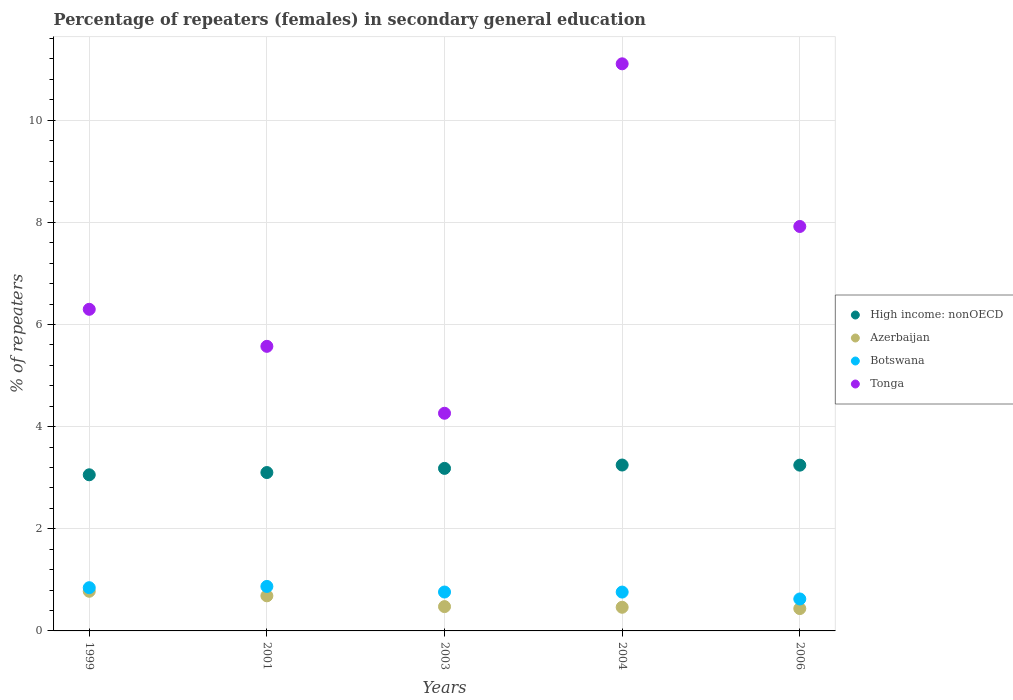How many different coloured dotlines are there?
Provide a succinct answer. 4. Is the number of dotlines equal to the number of legend labels?
Give a very brief answer. Yes. What is the percentage of female repeaters in High income: nonOECD in 2006?
Your answer should be very brief. 3.25. Across all years, what is the maximum percentage of female repeaters in High income: nonOECD?
Make the answer very short. 3.25. Across all years, what is the minimum percentage of female repeaters in Tonga?
Make the answer very short. 4.26. What is the total percentage of female repeaters in Botswana in the graph?
Provide a succinct answer. 3.87. What is the difference between the percentage of female repeaters in Azerbaijan in 2003 and that in 2004?
Give a very brief answer. 0.01. What is the difference between the percentage of female repeaters in Azerbaijan in 2006 and the percentage of female repeaters in Botswana in 2003?
Ensure brevity in your answer.  -0.32. What is the average percentage of female repeaters in Tonga per year?
Give a very brief answer. 7.03. In the year 2003, what is the difference between the percentage of female repeaters in Botswana and percentage of female repeaters in High income: nonOECD?
Offer a very short reply. -2.42. What is the ratio of the percentage of female repeaters in High income: nonOECD in 2004 to that in 2006?
Offer a very short reply. 1. Is the difference between the percentage of female repeaters in Botswana in 1999 and 2006 greater than the difference between the percentage of female repeaters in High income: nonOECD in 1999 and 2006?
Your answer should be compact. Yes. What is the difference between the highest and the second highest percentage of female repeaters in Azerbaijan?
Provide a succinct answer. 0.09. What is the difference between the highest and the lowest percentage of female repeaters in Botswana?
Offer a terse response. 0.25. Is the percentage of female repeaters in Tonga strictly greater than the percentage of female repeaters in High income: nonOECD over the years?
Make the answer very short. Yes. Are the values on the major ticks of Y-axis written in scientific E-notation?
Make the answer very short. No. Does the graph contain any zero values?
Offer a terse response. No. Does the graph contain grids?
Keep it short and to the point. Yes. How are the legend labels stacked?
Make the answer very short. Vertical. What is the title of the graph?
Keep it short and to the point. Percentage of repeaters (females) in secondary general education. What is the label or title of the Y-axis?
Ensure brevity in your answer.  % of repeaters. What is the % of repeaters in High income: nonOECD in 1999?
Your answer should be compact. 3.06. What is the % of repeaters in Azerbaijan in 1999?
Provide a short and direct response. 0.78. What is the % of repeaters in Botswana in 1999?
Ensure brevity in your answer.  0.85. What is the % of repeaters in Tonga in 1999?
Your answer should be very brief. 6.3. What is the % of repeaters of High income: nonOECD in 2001?
Offer a terse response. 3.1. What is the % of repeaters in Azerbaijan in 2001?
Offer a very short reply. 0.69. What is the % of repeaters in Botswana in 2001?
Provide a short and direct response. 0.87. What is the % of repeaters of Tonga in 2001?
Your response must be concise. 5.57. What is the % of repeaters in High income: nonOECD in 2003?
Make the answer very short. 3.18. What is the % of repeaters of Azerbaijan in 2003?
Make the answer very short. 0.48. What is the % of repeaters of Botswana in 2003?
Provide a succinct answer. 0.76. What is the % of repeaters of Tonga in 2003?
Your answer should be very brief. 4.26. What is the % of repeaters of High income: nonOECD in 2004?
Provide a succinct answer. 3.25. What is the % of repeaters of Azerbaijan in 2004?
Offer a very short reply. 0.46. What is the % of repeaters in Botswana in 2004?
Give a very brief answer. 0.76. What is the % of repeaters in Tonga in 2004?
Keep it short and to the point. 11.1. What is the % of repeaters of High income: nonOECD in 2006?
Ensure brevity in your answer.  3.25. What is the % of repeaters in Azerbaijan in 2006?
Provide a short and direct response. 0.44. What is the % of repeaters of Botswana in 2006?
Offer a very short reply. 0.63. What is the % of repeaters in Tonga in 2006?
Provide a succinct answer. 7.92. Across all years, what is the maximum % of repeaters in High income: nonOECD?
Give a very brief answer. 3.25. Across all years, what is the maximum % of repeaters in Azerbaijan?
Your answer should be compact. 0.78. Across all years, what is the maximum % of repeaters of Botswana?
Ensure brevity in your answer.  0.87. Across all years, what is the maximum % of repeaters of Tonga?
Keep it short and to the point. 11.1. Across all years, what is the minimum % of repeaters in High income: nonOECD?
Provide a succinct answer. 3.06. Across all years, what is the minimum % of repeaters of Azerbaijan?
Keep it short and to the point. 0.44. Across all years, what is the minimum % of repeaters in Botswana?
Your response must be concise. 0.63. Across all years, what is the minimum % of repeaters of Tonga?
Give a very brief answer. 4.26. What is the total % of repeaters of High income: nonOECD in the graph?
Ensure brevity in your answer.  15.84. What is the total % of repeaters in Azerbaijan in the graph?
Your answer should be compact. 2.84. What is the total % of repeaters in Botswana in the graph?
Your answer should be compact. 3.87. What is the total % of repeaters of Tonga in the graph?
Your answer should be very brief. 35.16. What is the difference between the % of repeaters in High income: nonOECD in 1999 and that in 2001?
Provide a short and direct response. -0.04. What is the difference between the % of repeaters of Azerbaijan in 1999 and that in 2001?
Keep it short and to the point. 0.09. What is the difference between the % of repeaters of Botswana in 1999 and that in 2001?
Your answer should be compact. -0.02. What is the difference between the % of repeaters of Tonga in 1999 and that in 2001?
Keep it short and to the point. 0.73. What is the difference between the % of repeaters in High income: nonOECD in 1999 and that in 2003?
Offer a very short reply. -0.13. What is the difference between the % of repeaters in Azerbaijan in 1999 and that in 2003?
Give a very brief answer. 0.3. What is the difference between the % of repeaters of Botswana in 1999 and that in 2003?
Your response must be concise. 0.08. What is the difference between the % of repeaters in Tonga in 1999 and that in 2003?
Your answer should be very brief. 2.04. What is the difference between the % of repeaters of High income: nonOECD in 1999 and that in 2004?
Provide a short and direct response. -0.19. What is the difference between the % of repeaters in Azerbaijan in 1999 and that in 2004?
Keep it short and to the point. 0.31. What is the difference between the % of repeaters in Botswana in 1999 and that in 2004?
Your answer should be very brief. 0.09. What is the difference between the % of repeaters of Tonga in 1999 and that in 2004?
Give a very brief answer. -4.81. What is the difference between the % of repeaters of High income: nonOECD in 1999 and that in 2006?
Make the answer very short. -0.19. What is the difference between the % of repeaters in Azerbaijan in 1999 and that in 2006?
Offer a terse response. 0.34. What is the difference between the % of repeaters in Botswana in 1999 and that in 2006?
Provide a short and direct response. 0.22. What is the difference between the % of repeaters of Tonga in 1999 and that in 2006?
Offer a very short reply. -1.62. What is the difference between the % of repeaters of High income: nonOECD in 2001 and that in 2003?
Your response must be concise. -0.08. What is the difference between the % of repeaters in Azerbaijan in 2001 and that in 2003?
Give a very brief answer. 0.21. What is the difference between the % of repeaters of Botswana in 2001 and that in 2003?
Give a very brief answer. 0.11. What is the difference between the % of repeaters of Tonga in 2001 and that in 2003?
Keep it short and to the point. 1.31. What is the difference between the % of repeaters in High income: nonOECD in 2001 and that in 2004?
Ensure brevity in your answer.  -0.15. What is the difference between the % of repeaters of Azerbaijan in 2001 and that in 2004?
Provide a short and direct response. 0.22. What is the difference between the % of repeaters in Botswana in 2001 and that in 2004?
Make the answer very short. 0.11. What is the difference between the % of repeaters of Tonga in 2001 and that in 2004?
Your answer should be very brief. -5.53. What is the difference between the % of repeaters in High income: nonOECD in 2001 and that in 2006?
Your response must be concise. -0.14. What is the difference between the % of repeaters in Azerbaijan in 2001 and that in 2006?
Provide a short and direct response. 0.25. What is the difference between the % of repeaters in Botswana in 2001 and that in 2006?
Your response must be concise. 0.25. What is the difference between the % of repeaters of Tonga in 2001 and that in 2006?
Provide a short and direct response. -2.35. What is the difference between the % of repeaters in High income: nonOECD in 2003 and that in 2004?
Provide a short and direct response. -0.07. What is the difference between the % of repeaters in Azerbaijan in 2003 and that in 2004?
Offer a very short reply. 0.01. What is the difference between the % of repeaters of Tonga in 2003 and that in 2004?
Keep it short and to the point. -6.84. What is the difference between the % of repeaters of High income: nonOECD in 2003 and that in 2006?
Your answer should be very brief. -0.06. What is the difference between the % of repeaters of Azerbaijan in 2003 and that in 2006?
Make the answer very short. 0.04. What is the difference between the % of repeaters in Botswana in 2003 and that in 2006?
Give a very brief answer. 0.14. What is the difference between the % of repeaters in Tonga in 2003 and that in 2006?
Provide a succinct answer. -3.66. What is the difference between the % of repeaters of High income: nonOECD in 2004 and that in 2006?
Make the answer very short. 0. What is the difference between the % of repeaters of Azerbaijan in 2004 and that in 2006?
Give a very brief answer. 0.03. What is the difference between the % of repeaters in Botswana in 2004 and that in 2006?
Ensure brevity in your answer.  0.13. What is the difference between the % of repeaters in Tonga in 2004 and that in 2006?
Your answer should be compact. 3.19. What is the difference between the % of repeaters in High income: nonOECD in 1999 and the % of repeaters in Azerbaijan in 2001?
Offer a very short reply. 2.37. What is the difference between the % of repeaters in High income: nonOECD in 1999 and the % of repeaters in Botswana in 2001?
Make the answer very short. 2.19. What is the difference between the % of repeaters in High income: nonOECD in 1999 and the % of repeaters in Tonga in 2001?
Give a very brief answer. -2.52. What is the difference between the % of repeaters in Azerbaijan in 1999 and the % of repeaters in Botswana in 2001?
Keep it short and to the point. -0.09. What is the difference between the % of repeaters in Azerbaijan in 1999 and the % of repeaters in Tonga in 2001?
Your response must be concise. -4.8. What is the difference between the % of repeaters in Botswana in 1999 and the % of repeaters in Tonga in 2001?
Provide a succinct answer. -4.73. What is the difference between the % of repeaters in High income: nonOECD in 1999 and the % of repeaters in Azerbaijan in 2003?
Make the answer very short. 2.58. What is the difference between the % of repeaters of High income: nonOECD in 1999 and the % of repeaters of Botswana in 2003?
Offer a very short reply. 2.3. What is the difference between the % of repeaters in High income: nonOECD in 1999 and the % of repeaters in Tonga in 2003?
Give a very brief answer. -1.21. What is the difference between the % of repeaters of Azerbaijan in 1999 and the % of repeaters of Botswana in 2003?
Offer a very short reply. 0.01. What is the difference between the % of repeaters in Azerbaijan in 1999 and the % of repeaters in Tonga in 2003?
Offer a very short reply. -3.49. What is the difference between the % of repeaters in Botswana in 1999 and the % of repeaters in Tonga in 2003?
Offer a terse response. -3.42. What is the difference between the % of repeaters in High income: nonOECD in 1999 and the % of repeaters in Azerbaijan in 2004?
Your answer should be compact. 2.59. What is the difference between the % of repeaters in High income: nonOECD in 1999 and the % of repeaters in Botswana in 2004?
Make the answer very short. 2.3. What is the difference between the % of repeaters of High income: nonOECD in 1999 and the % of repeaters of Tonga in 2004?
Ensure brevity in your answer.  -8.05. What is the difference between the % of repeaters in Azerbaijan in 1999 and the % of repeaters in Botswana in 2004?
Your answer should be compact. 0.02. What is the difference between the % of repeaters in Azerbaijan in 1999 and the % of repeaters in Tonga in 2004?
Keep it short and to the point. -10.33. What is the difference between the % of repeaters in Botswana in 1999 and the % of repeaters in Tonga in 2004?
Provide a succinct answer. -10.26. What is the difference between the % of repeaters in High income: nonOECD in 1999 and the % of repeaters in Azerbaijan in 2006?
Keep it short and to the point. 2.62. What is the difference between the % of repeaters in High income: nonOECD in 1999 and the % of repeaters in Botswana in 2006?
Give a very brief answer. 2.43. What is the difference between the % of repeaters of High income: nonOECD in 1999 and the % of repeaters of Tonga in 2006?
Provide a succinct answer. -4.86. What is the difference between the % of repeaters of Azerbaijan in 1999 and the % of repeaters of Botswana in 2006?
Provide a succinct answer. 0.15. What is the difference between the % of repeaters in Azerbaijan in 1999 and the % of repeaters in Tonga in 2006?
Make the answer very short. -7.14. What is the difference between the % of repeaters of Botswana in 1999 and the % of repeaters of Tonga in 2006?
Your answer should be compact. -7.07. What is the difference between the % of repeaters in High income: nonOECD in 2001 and the % of repeaters in Azerbaijan in 2003?
Your response must be concise. 2.63. What is the difference between the % of repeaters in High income: nonOECD in 2001 and the % of repeaters in Botswana in 2003?
Offer a terse response. 2.34. What is the difference between the % of repeaters in High income: nonOECD in 2001 and the % of repeaters in Tonga in 2003?
Keep it short and to the point. -1.16. What is the difference between the % of repeaters of Azerbaijan in 2001 and the % of repeaters of Botswana in 2003?
Offer a very short reply. -0.07. What is the difference between the % of repeaters of Azerbaijan in 2001 and the % of repeaters of Tonga in 2003?
Keep it short and to the point. -3.58. What is the difference between the % of repeaters of Botswana in 2001 and the % of repeaters of Tonga in 2003?
Provide a short and direct response. -3.39. What is the difference between the % of repeaters of High income: nonOECD in 2001 and the % of repeaters of Azerbaijan in 2004?
Provide a short and direct response. 2.64. What is the difference between the % of repeaters in High income: nonOECD in 2001 and the % of repeaters in Botswana in 2004?
Offer a very short reply. 2.34. What is the difference between the % of repeaters in High income: nonOECD in 2001 and the % of repeaters in Tonga in 2004?
Your response must be concise. -8. What is the difference between the % of repeaters in Azerbaijan in 2001 and the % of repeaters in Botswana in 2004?
Ensure brevity in your answer.  -0.07. What is the difference between the % of repeaters of Azerbaijan in 2001 and the % of repeaters of Tonga in 2004?
Offer a very short reply. -10.42. What is the difference between the % of repeaters of Botswana in 2001 and the % of repeaters of Tonga in 2004?
Ensure brevity in your answer.  -10.23. What is the difference between the % of repeaters in High income: nonOECD in 2001 and the % of repeaters in Azerbaijan in 2006?
Provide a short and direct response. 2.66. What is the difference between the % of repeaters of High income: nonOECD in 2001 and the % of repeaters of Botswana in 2006?
Ensure brevity in your answer.  2.48. What is the difference between the % of repeaters in High income: nonOECD in 2001 and the % of repeaters in Tonga in 2006?
Ensure brevity in your answer.  -4.82. What is the difference between the % of repeaters in Azerbaijan in 2001 and the % of repeaters in Botswana in 2006?
Give a very brief answer. 0.06. What is the difference between the % of repeaters of Azerbaijan in 2001 and the % of repeaters of Tonga in 2006?
Ensure brevity in your answer.  -7.23. What is the difference between the % of repeaters of Botswana in 2001 and the % of repeaters of Tonga in 2006?
Your answer should be compact. -7.05. What is the difference between the % of repeaters in High income: nonOECD in 2003 and the % of repeaters in Azerbaijan in 2004?
Your response must be concise. 2.72. What is the difference between the % of repeaters in High income: nonOECD in 2003 and the % of repeaters in Botswana in 2004?
Your response must be concise. 2.42. What is the difference between the % of repeaters of High income: nonOECD in 2003 and the % of repeaters of Tonga in 2004?
Offer a very short reply. -7.92. What is the difference between the % of repeaters of Azerbaijan in 2003 and the % of repeaters of Botswana in 2004?
Offer a terse response. -0.28. What is the difference between the % of repeaters of Azerbaijan in 2003 and the % of repeaters of Tonga in 2004?
Your answer should be very brief. -10.63. What is the difference between the % of repeaters in Botswana in 2003 and the % of repeaters in Tonga in 2004?
Provide a succinct answer. -10.34. What is the difference between the % of repeaters in High income: nonOECD in 2003 and the % of repeaters in Azerbaijan in 2006?
Keep it short and to the point. 2.74. What is the difference between the % of repeaters of High income: nonOECD in 2003 and the % of repeaters of Botswana in 2006?
Your answer should be very brief. 2.56. What is the difference between the % of repeaters in High income: nonOECD in 2003 and the % of repeaters in Tonga in 2006?
Provide a succinct answer. -4.74. What is the difference between the % of repeaters in Azerbaijan in 2003 and the % of repeaters in Botswana in 2006?
Provide a succinct answer. -0.15. What is the difference between the % of repeaters in Azerbaijan in 2003 and the % of repeaters in Tonga in 2006?
Make the answer very short. -7.44. What is the difference between the % of repeaters in Botswana in 2003 and the % of repeaters in Tonga in 2006?
Ensure brevity in your answer.  -7.16. What is the difference between the % of repeaters in High income: nonOECD in 2004 and the % of repeaters in Azerbaijan in 2006?
Your response must be concise. 2.81. What is the difference between the % of repeaters in High income: nonOECD in 2004 and the % of repeaters in Botswana in 2006?
Offer a terse response. 2.62. What is the difference between the % of repeaters in High income: nonOECD in 2004 and the % of repeaters in Tonga in 2006?
Make the answer very short. -4.67. What is the difference between the % of repeaters in Azerbaijan in 2004 and the % of repeaters in Botswana in 2006?
Give a very brief answer. -0.16. What is the difference between the % of repeaters of Azerbaijan in 2004 and the % of repeaters of Tonga in 2006?
Ensure brevity in your answer.  -7.46. What is the difference between the % of repeaters in Botswana in 2004 and the % of repeaters in Tonga in 2006?
Offer a very short reply. -7.16. What is the average % of repeaters of High income: nonOECD per year?
Keep it short and to the point. 3.17. What is the average % of repeaters of Azerbaijan per year?
Keep it short and to the point. 0.57. What is the average % of repeaters in Botswana per year?
Your response must be concise. 0.77. What is the average % of repeaters of Tonga per year?
Offer a terse response. 7.03. In the year 1999, what is the difference between the % of repeaters of High income: nonOECD and % of repeaters of Azerbaijan?
Give a very brief answer. 2.28. In the year 1999, what is the difference between the % of repeaters of High income: nonOECD and % of repeaters of Botswana?
Make the answer very short. 2.21. In the year 1999, what is the difference between the % of repeaters in High income: nonOECD and % of repeaters in Tonga?
Ensure brevity in your answer.  -3.24. In the year 1999, what is the difference between the % of repeaters of Azerbaijan and % of repeaters of Botswana?
Provide a short and direct response. -0.07. In the year 1999, what is the difference between the % of repeaters of Azerbaijan and % of repeaters of Tonga?
Provide a succinct answer. -5.52. In the year 1999, what is the difference between the % of repeaters in Botswana and % of repeaters in Tonga?
Keep it short and to the point. -5.45. In the year 2001, what is the difference between the % of repeaters of High income: nonOECD and % of repeaters of Azerbaijan?
Offer a terse response. 2.41. In the year 2001, what is the difference between the % of repeaters of High income: nonOECD and % of repeaters of Botswana?
Your answer should be compact. 2.23. In the year 2001, what is the difference between the % of repeaters of High income: nonOECD and % of repeaters of Tonga?
Offer a very short reply. -2.47. In the year 2001, what is the difference between the % of repeaters in Azerbaijan and % of repeaters in Botswana?
Offer a terse response. -0.18. In the year 2001, what is the difference between the % of repeaters in Azerbaijan and % of repeaters in Tonga?
Make the answer very short. -4.89. In the year 2001, what is the difference between the % of repeaters in Botswana and % of repeaters in Tonga?
Provide a succinct answer. -4.7. In the year 2003, what is the difference between the % of repeaters of High income: nonOECD and % of repeaters of Azerbaijan?
Offer a terse response. 2.71. In the year 2003, what is the difference between the % of repeaters in High income: nonOECD and % of repeaters in Botswana?
Your response must be concise. 2.42. In the year 2003, what is the difference between the % of repeaters in High income: nonOECD and % of repeaters in Tonga?
Offer a terse response. -1.08. In the year 2003, what is the difference between the % of repeaters in Azerbaijan and % of repeaters in Botswana?
Your answer should be very brief. -0.29. In the year 2003, what is the difference between the % of repeaters in Azerbaijan and % of repeaters in Tonga?
Provide a short and direct response. -3.79. In the year 2003, what is the difference between the % of repeaters in Botswana and % of repeaters in Tonga?
Offer a terse response. -3.5. In the year 2004, what is the difference between the % of repeaters of High income: nonOECD and % of repeaters of Azerbaijan?
Ensure brevity in your answer.  2.79. In the year 2004, what is the difference between the % of repeaters in High income: nonOECD and % of repeaters in Botswana?
Provide a short and direct response. 2.49. In the year 2004, what is the difference between the % of repeaters of High income: nonOECD and % of repeaters of Tonga?
Make the answer very short. -7.86. In the year 2004, what is the difference between the % of repeaters of Azerbaijan and % of repeaters of Botswana?
Your response must be concise. -0.3. In the year 2004, what is the difference between the % of repeaters in Azerbaijan and % of repeaters in Tonga?
Your response must be concise. -10.64. In the year 2004, what is the difference between the % of repeaters in Botswana and % of repeaters in Tonga?
Make the answer very short. -10.34. In the year 2006, what is the difference between the % of repeaters of High income: nonOECD and % of repeaters of Azerbaijan?
Provide a short and direct response. 2.81. In the year 2006, what is the difference between the % of repeaters in High income: nonOECD and % of repeaters in Botswana?
Provide a succinct answer. 2.62. In the year 2006, what is the difference between the % of repeaters of High income: nonOECD and % of repeaters of Tonga?
Your answer should be very brief. -4.67. In the year 2006, what is the difference between the % of repeaters of Azerbaijan and % of repeaters of Botswana?
Keep it short and to the point. -0.19. In the year 2006, what is the difference between the % of repeaters of Azerbaijan and % of repeaters of Tonga?
Your answer should be compact. -7.48. In the year 2006, what is the difference between the % of repeaters of Botswana and % of repeaters of Tonga?
Your answer should be compact. -7.29. What is the ratio of the % of repeaters of High income: nonOECD in 1999 to that in 2001?
Keep it short and to the point. 0.99. What is the ratio of the % of repeaters in Azerbaijan in 1999 to that in 2001?
Ensure brevity in your answer.  1.13. What is the ratio of the % of repeaters in Botswana in 1999 to that in 2001?
Provide a short and direct response. 0.97. What is the ratio of the % of repeaters in Tonga in 1999 to that in 2001?
Keep it short and to the point. 1.13. What is the ratio of the % of repeaters in High income: nonOECD in 1999 to that in 2003?
Keep it short and to the point. 0.96. What is the ratio of the % of repeaters in Azerbaijan in 1999 to that in 2003?
Give a very brief answer. 1.63. What is the ratio of the % of repeaters in Botswana in 1999 to that in 2003?
Ensure brevity in your answer.  1.11. What is the ratio of the % of repeaters in Tonga in 1999 to that in 2003?
Ensure brevity in your answer.  1.48. What is the ratio of the % of repeaters in High income: nonOECD in 1999 to that in 2004?
Your response must be concise. 0.94. What is the ratio of the % of repeaters in Azerbaijan in 1999 to that in 2004?
Provide a succinct answer. 1.68. What is the ratio of the % of repeaters in Botswana in 1999 to that in 2004?
Provide a short and direct response. 1.11. What is the ratio of the % of repeaters in Tonga in 1999 to that in 2004?
Give a very brief answer. 0.57. What is the ratio of the % of repeaters in High income: nonOECD in 1999 to that in 2006?
Make the answer very short. 0.94. What is the ratio of the % of repeaters of Azerbaijan in 1999 to that in 2006?
Ensure brevity in your answer.  1.77. What is the ratio of the % of repeaters of Botswana in 1999 to that in 2006?
Make the answer very short. 1.35. What is the ratio of the % of repeaters in Tonga in 1999 to that in 2006?
Ensure brevity in your answer.  0.8. What is the ratio of the % of repeaters of High income: nonOECD in 2001 to that in 2003?
Keep it short and to the point. 0.97. What is the ratio of the % of repeaters of Azerbaijan in 2001 to that in 2003?
Provide a short and direct response. 1.44. What is the ratio of the % of repeaters in Botswana in 2001 to that in 2003?
Your answer should be compact. 1.14. What is the ratio of the % of repeaters of Tonga in 2001 to that in 2003?
Provide a succinct answer. 1.31. What is the ratio of the % of repeaters in High income: nonOECD in 2001 to that in 2004?
Make the answer very short. 0.95. What is the ratio of the % of repeaters of Azerbaijan in 2001 to that in 2004?
Make the answer very short. 1.48. What is the ratio of the % of repeaters in Botswana in 2001 to that in 2004?
Provide a short and direct response. 1.15. What is the ratio of the % of repeaters in Tonga in 2001 to that in 2004?
Your answer should be very brief. 0.5. What is the ratio of the % of repeaters in High income: nonOECD in 2001 to that in 2006?
Offer a terse response. 0.96. What is the ratio of the % of repeaters of Azerbaijan in 2001 to that in 2006?
Keep it short and to the point. 1.57. What is the ratio of the % of repeaters in Botswana in 2001 to that in 2006?
Offer a terse response. 1.39. What is the ratio of the % of repeaters of Tonga in 2001 to that in 2006?
Provide a short and direct response. 0.7. What is the ratio of the % of repeaters of High income: nonOECD in 2003 to that in 2004?
Provide a short and direct response. 0.98. What is the ratio of the % of repeaters in Azerbaijan in 2003 to that in 2004?
Provide a short and direct response. 1.03. What is the ratio of the % of repeaters of Tonga in 2003 to that in 2004?
Your response must be concise. 0.38. What is the ratio of the % of repeaters of High income: nonOECD in 2003 to that in 2006?
Your response must be concise. 0.98. What is the ratio of the % of repeaters of Azerbaijan in 2003 to that in 2006?
Provide a succinct answer. 1.09. What is the ratio of the % of repeaters in Botswana in 2003 to that in 2006?
Provide a short and direct response. 1.22. What is the ratio of the % of repeaters of Tonga in 2003 to that in 2006?
Provide a short and direct response. 0.54. What is the ratio of the % of repeaters in Azerbaijan in 2004 to that in 2006?
Make the answer very short. 1.06. What is the ratio of the % of repeaters in Botswana in 2004 to that in 2006?
Offer a terse response. 1.22. What is the ratio of the % of repeaters of Tonga in 2004 to that in 2006?
Provide a short and direct response. 1.4. What is the difference between the highest and the second highest % of repeaters of High income: nonOECD?
Your answer should be compact. 0. What is the difference between the highest and the second highest % of repeaters of Azerbaijan?
Your response must be concise. 0.09. What is the difference between the highest and the second highest % of repeaters in Botswana?
Keep it short and to the point. 0.02. What is the difference between the highest and the second highest % of repeaters in Tonga?
Keep it short and to the point. 3.19. What is the difference between the highest and the lowest % of repeaters of High income: nonOECD?
Keep it short and to the point. 0.19. What is the difference between the highest and the lowest % of repeaters of Azerbaijan?
Give a very brief answer. 0.34. What is the difference between the highest and the lowest % of repeaters in Botswana?
Provide a succinct answer. 0.25. What is the difference between the highest and the lowest % of repeaters in Tonga?
Your answer should be compact. 6.84. 